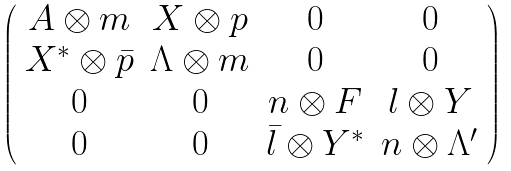<formula> <loc_0><loc_0><loc_500><loc_500>\left ( \begin{array} { c c c c } A \otimes m & X \otimes p & 0 & 0 \\ X ^ { \ast } \otimes \bar { p } & \Lambda \otimes m & 0 & 0 \\ 0 & 0 & n \otimes F & l \otimes Y \\ 0 & 0 & \bar { l } \otimes Y ^ { * } & n \otimes \Lambda ^ { \prime } \end{array} \right )</formula> 